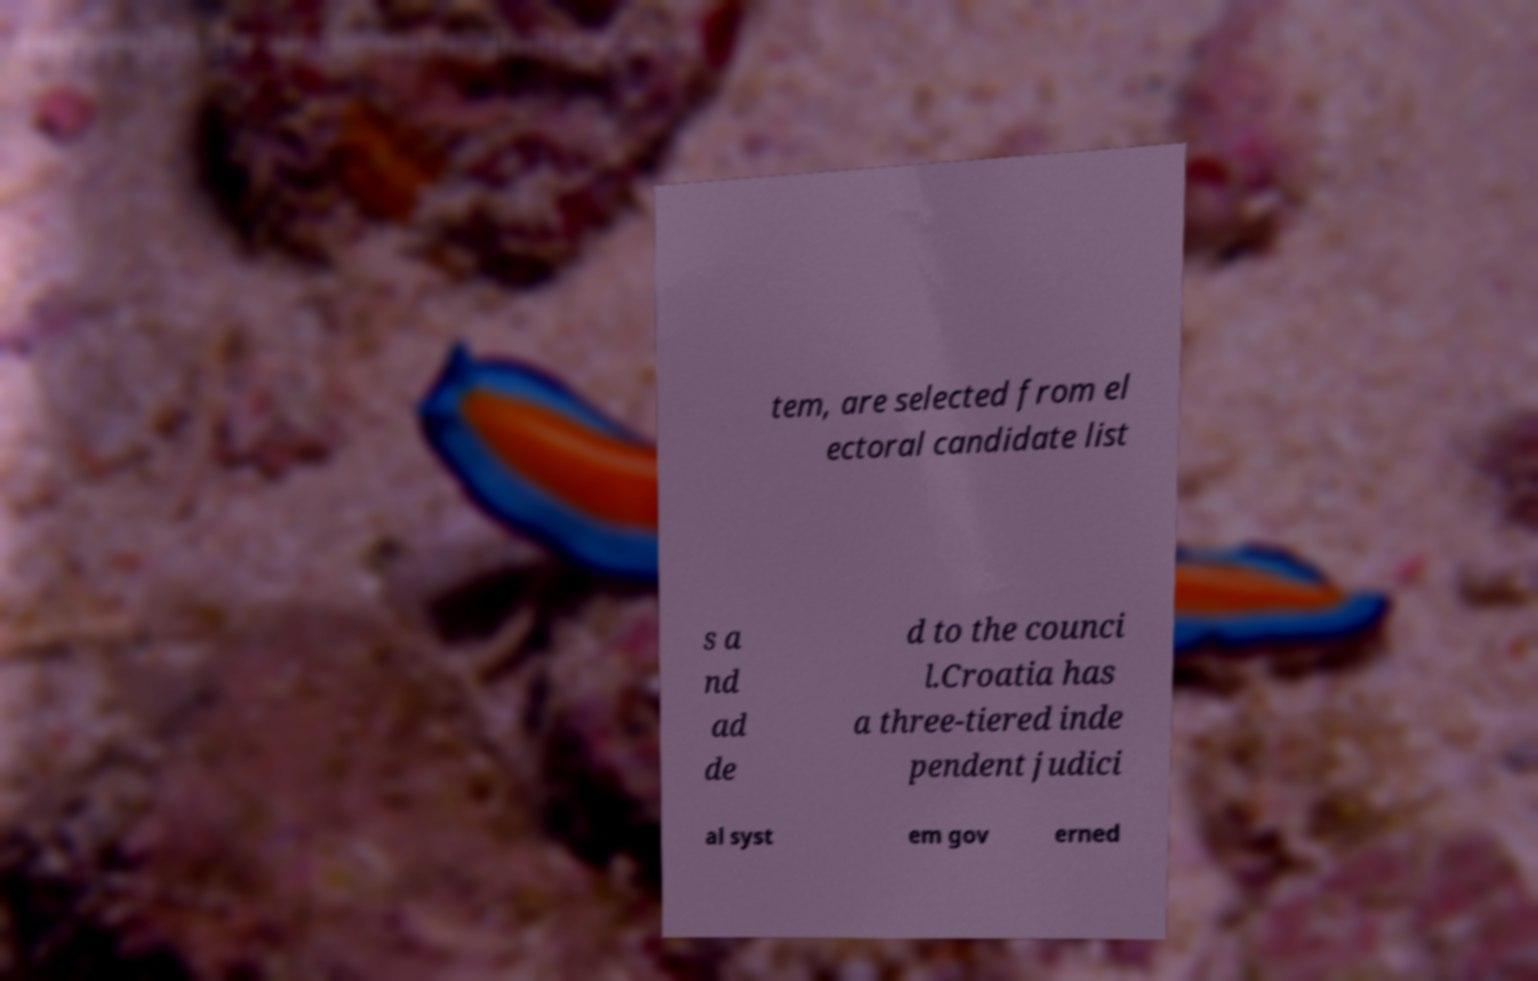Please read and relay the text visible in this image. What does it say? tem, are selected from el ectoral candidate list s a nd ad de d to the counci l.Croatia has a three-tiered inde pendent judici al syst em gov erned 